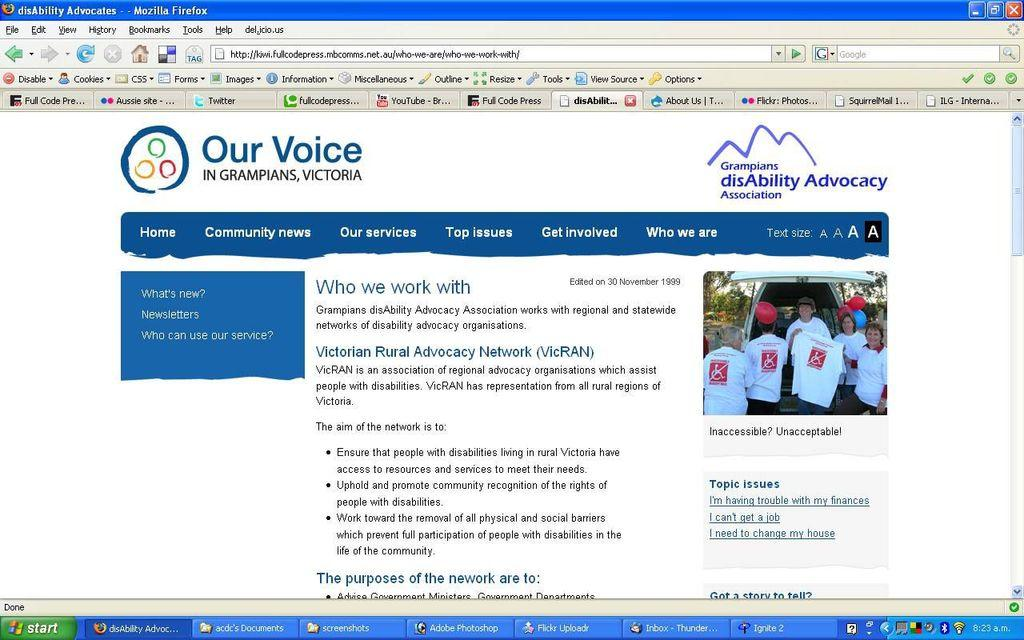What type of content is displayed in the image? The image contains a webpage. What visual element can be found on the webpage? The webpage has a picture. What type of information is available on the webpage? The webpage has text. Where is the search bar located on the webpage? There is a search bar at the top of the image. Can you tell me how many lawyers are visible in the image? There are no lawyers present in the image; it contains a webpage with a picture and text. What type of calculator is being used in the image? There is no calculator present in the image. 